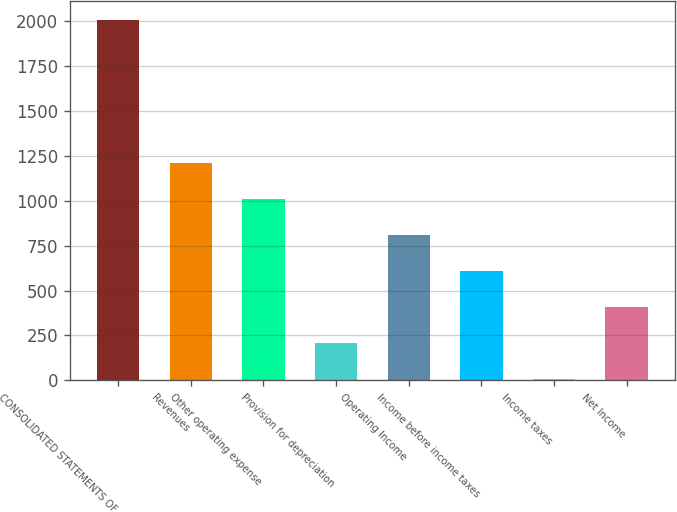Convert chart. <chart><loc_0><loc_0><loc_500><loc_500><bar_chart><fcel>CONSOLIDATED STATEMENTS OF<fcel>Revenues<fcel>Other operating expense<fcel>Provision for depreciation<fcel>Operating Income<fcel>Income before income taxes<fcel>Income taxes<fcel>Net Income<nl><fcel>2010<fcel>1208.12<fcel>1007.65<fcel>205.77<fcel>807.18<fcel>606.71<fcel>5.3<fcel>406.24<nl></chart> 